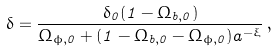Convert formula to latex. <formula><loc_0><loc_0><loc_500><loc_500>\delta = \frac { \delta _ { 0 } ( 1 - \Omega _ { b , 0 } ) } { \Omega _ { \phi , 0 } + ( 1 - \Omega _ { b , 0 } - \Omega _ { \phi , 0 } ) a ^ { - \xi } } \, ,</formula> 